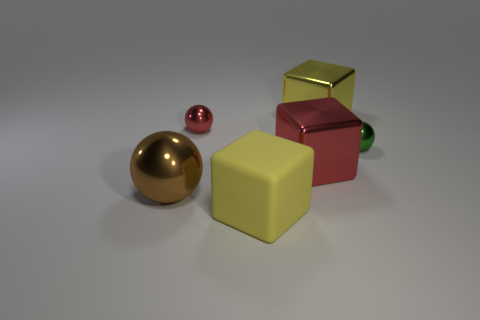Is there any other thing that has the same color as the large shiny ball?
Offer a terse response. No. There is a yellow rubber object that is the same size as the yellow shiny cube; what shape is it?
Offer a very short reply. Cube. Is there a large block of the same color as the large matte object?
Keep it short and to the point. Yes. Do the rubber object and the large block that is behind the red block have the same color?
Provide a short and direct response. Yes. What color is the tiny thing to the left of the tiny metal thing in front of the tiny red shiny ball?
Keep it short and to the point. Red. Are there any small green objects that are to the right of the big yellow cube left of the yellow block behind the brown object?
Offer a terse response. Yes. There is another large ball that is made of the same material as the red sphere; what is its color?
Give a very brief answer. Brown. How many small green cylinders are the same material as the small green sphere?
Provide a short and direct response. 0. Do the large sphere and the yellow cube that is in front of the tiny green metallic object have the same material?
Give a very brief answer. No. What number of things are either large objects behind the large brown object or large metallic things?
Make the answer very short. 3. 